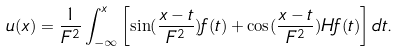<formula> <loc_0><loc_0><loc_500><loc_500>u ( x ) = \frac { 1 } { F ^ { 2 } } \int _ { - \infty } ^ { x } \left [ \sin ( \frac { x - t } { F ^ { 2 } } ) f ( t ) + \cos ( \frac { x - t } { F ^ { 2 } } ) H f ( t ) \right ] d t .</formula> 